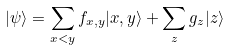Convert formula to latex. <formula><loc_0><loc_0><loc_500><loc_500>| \psi \rangle = \sum _ { x < y } f _ { x , y } | x , y \rangle + \sum _ { z } g _ { z } | z \rangle</formula> 